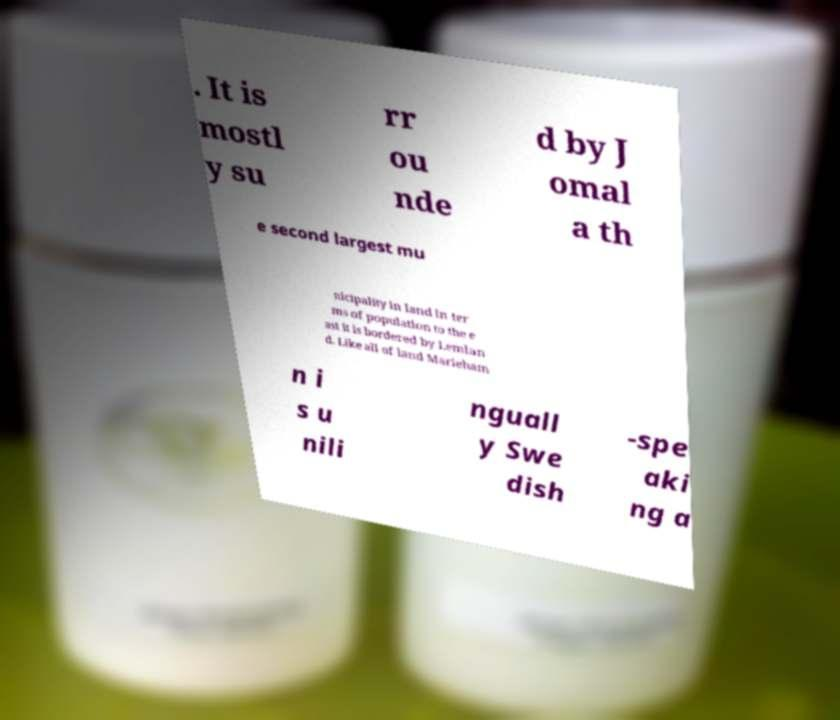I need the written content from this picture converted into text. Can you do that? . It is mostl y su rr ou nde d by J omal a th e second largest mu nicipality in land in ter ms of population to the e ast it is bordered by Lemlan d. Like all of land Marieham n i s u nili nguall y Swe dish -spe aki ng a 